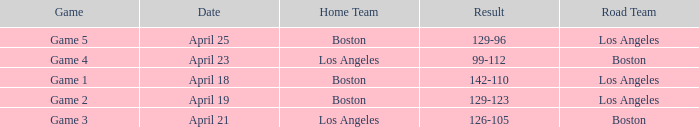WHAT GAME HAD A SCORE OF 99-112? Game 4. 